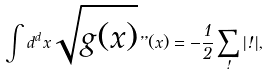<formula> <loc_0><loc_0><loc_500><loc_500>\int d ^ { d } x \sqrt { g ( x ) } \varepsilon ( x ) = - \frac { 1 } { 2 } \sum _ { \omega } | \omega | ,</formula> 